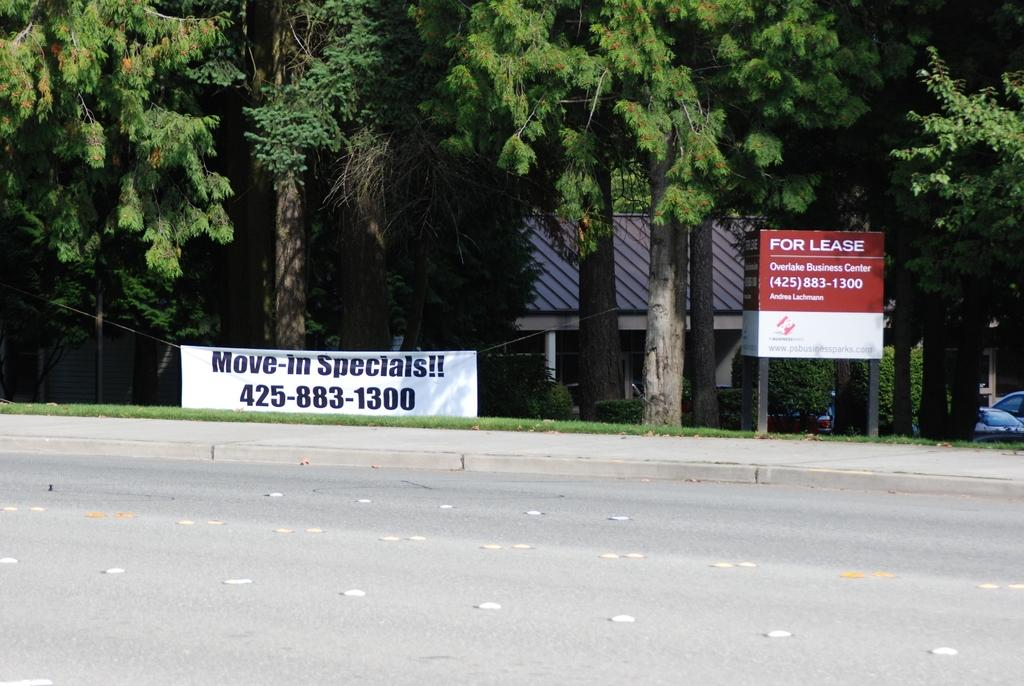What type of surface can be seen in the image? There is a road in the image. What is hanging or displayed in the image? There is a banner in the image. What type of vegetation is present in the image? There is grass and trees in the image. What type of structures can be seen in the image? There are houses in the image. What type of objects are moving or parked in the image? There are vehicles in the image. What type of display or advertisement is present in the image? There are posters on a stand in the image. What type of comfort can be seen in the image? There is no specific comfort item or feature present in the image. How much salt is visible in the image? There is no salt present in the image. 